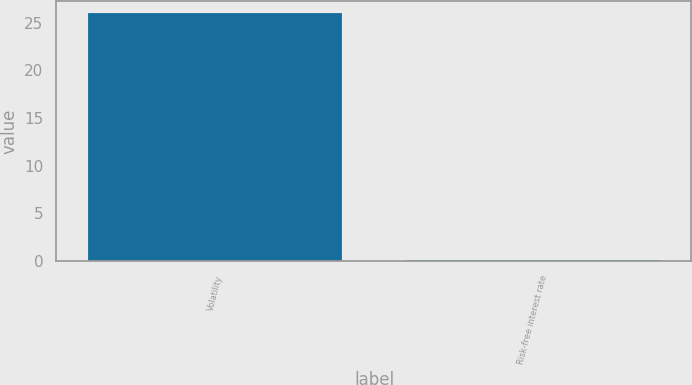Convert chart. <chart><loc_0><loc_0><loc_500><loc_500><bar_chart><fcel>Volatility<fcel>Risk-free interest rate<nl><fcel>26<fcel>0.14<nl></chart> 